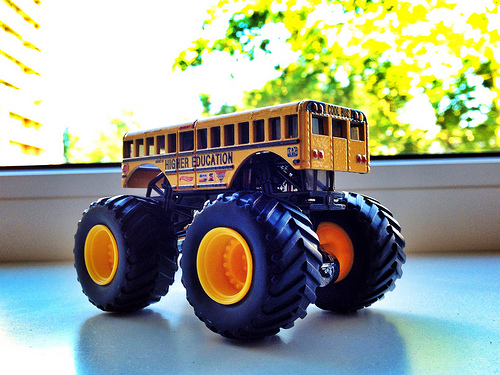<image>
Is there a window above the tire? No. The window is not positioned above the tire. The vertical arrangement shows a different relationship. 